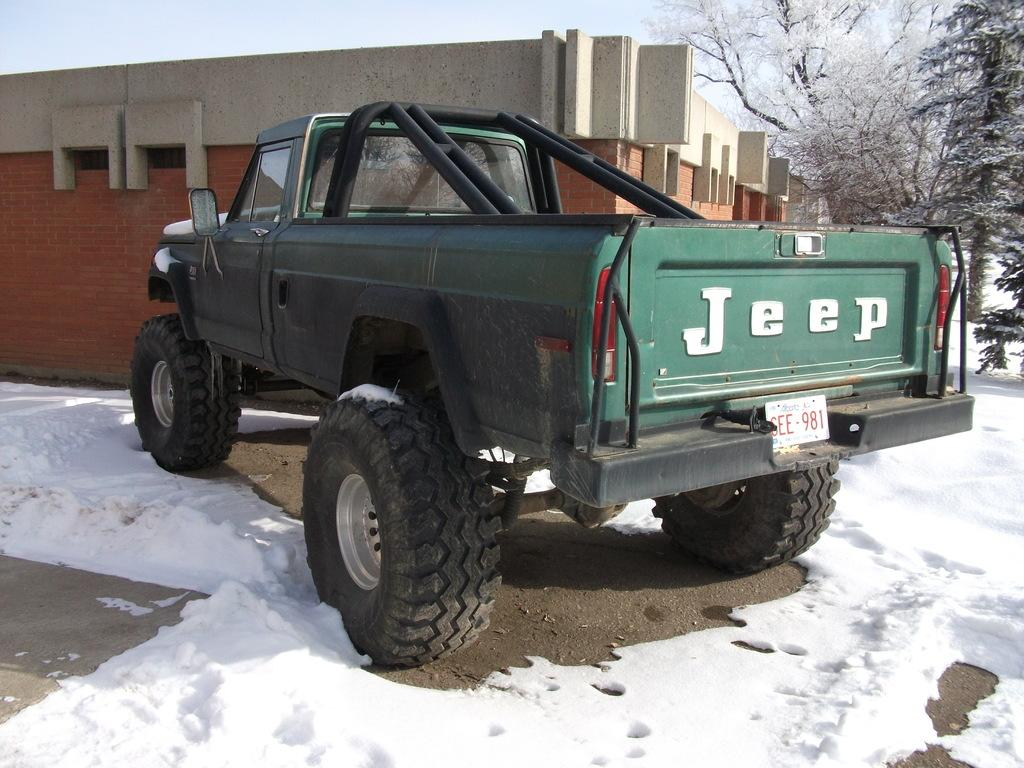What vehicle is in the image? There is a jeep in the image. Where is the jeep located? The jeep is on the road. What is the condition of the road in the image? The road is covered with snow. What other structures can be seen in the image? There is a building and trees in the image. What is visible in the background of the image? The sky is visible in the image. What type of shoes can be seen hanging from the trees in the image? There are no shoes present in the image; it features a jeep on a snow-covered road with a building and trees in the background. 